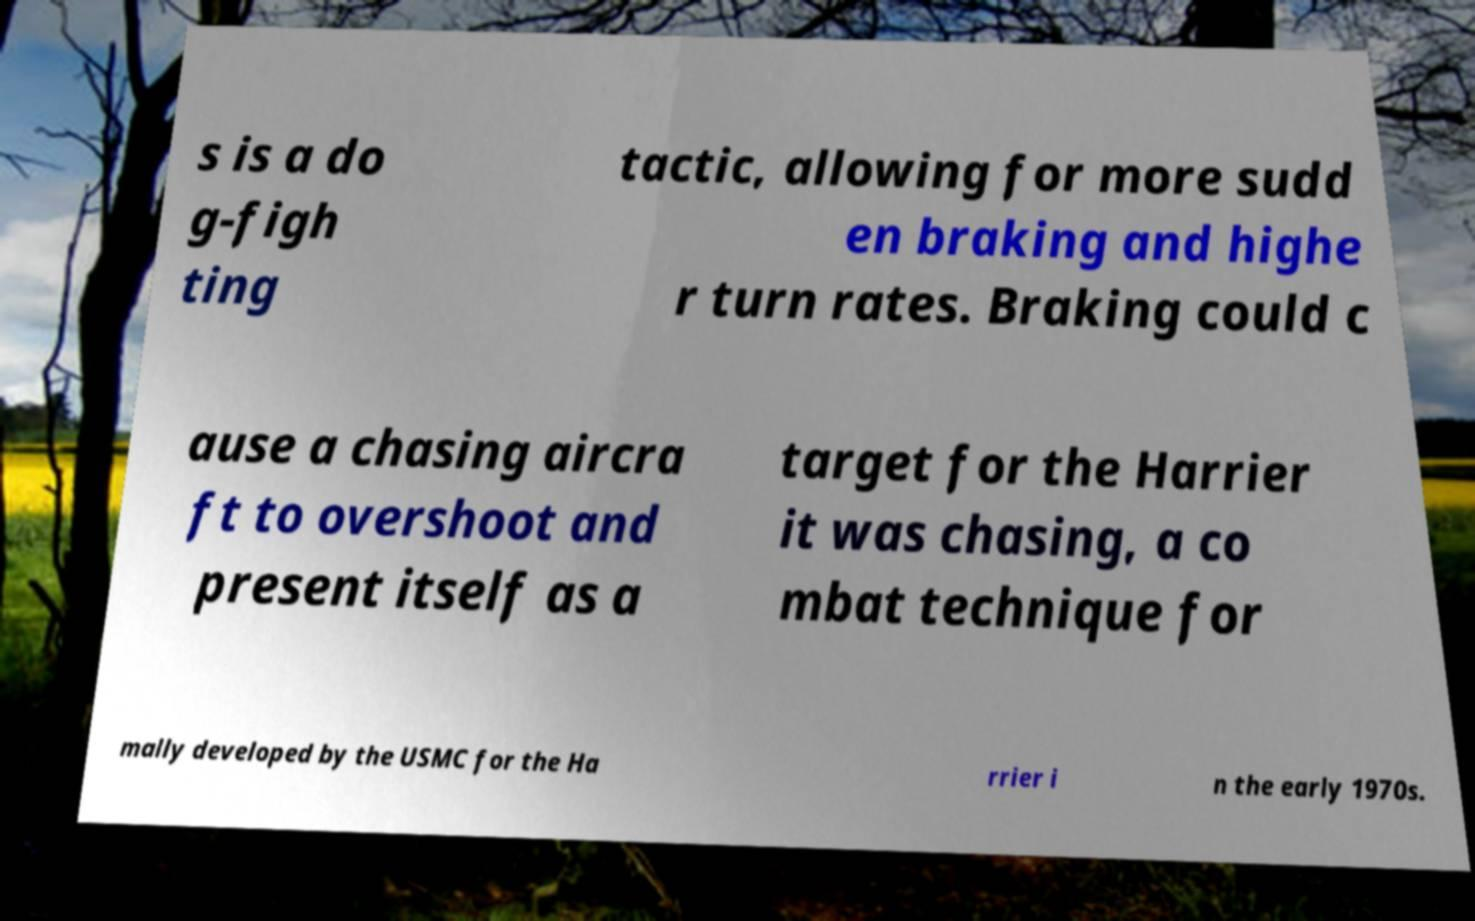Could you extract and type out the text from this image? s is a do g-figh ting tactic, allowing for more sudd en braking and highe r turn rates. Braking could c ause a chasing aircra ft to overshoot and present itself as a target for the Harrier it was chasing, a co mbat technique for mally developed by the USMC for the Ha rrier i n the early 1970s. 